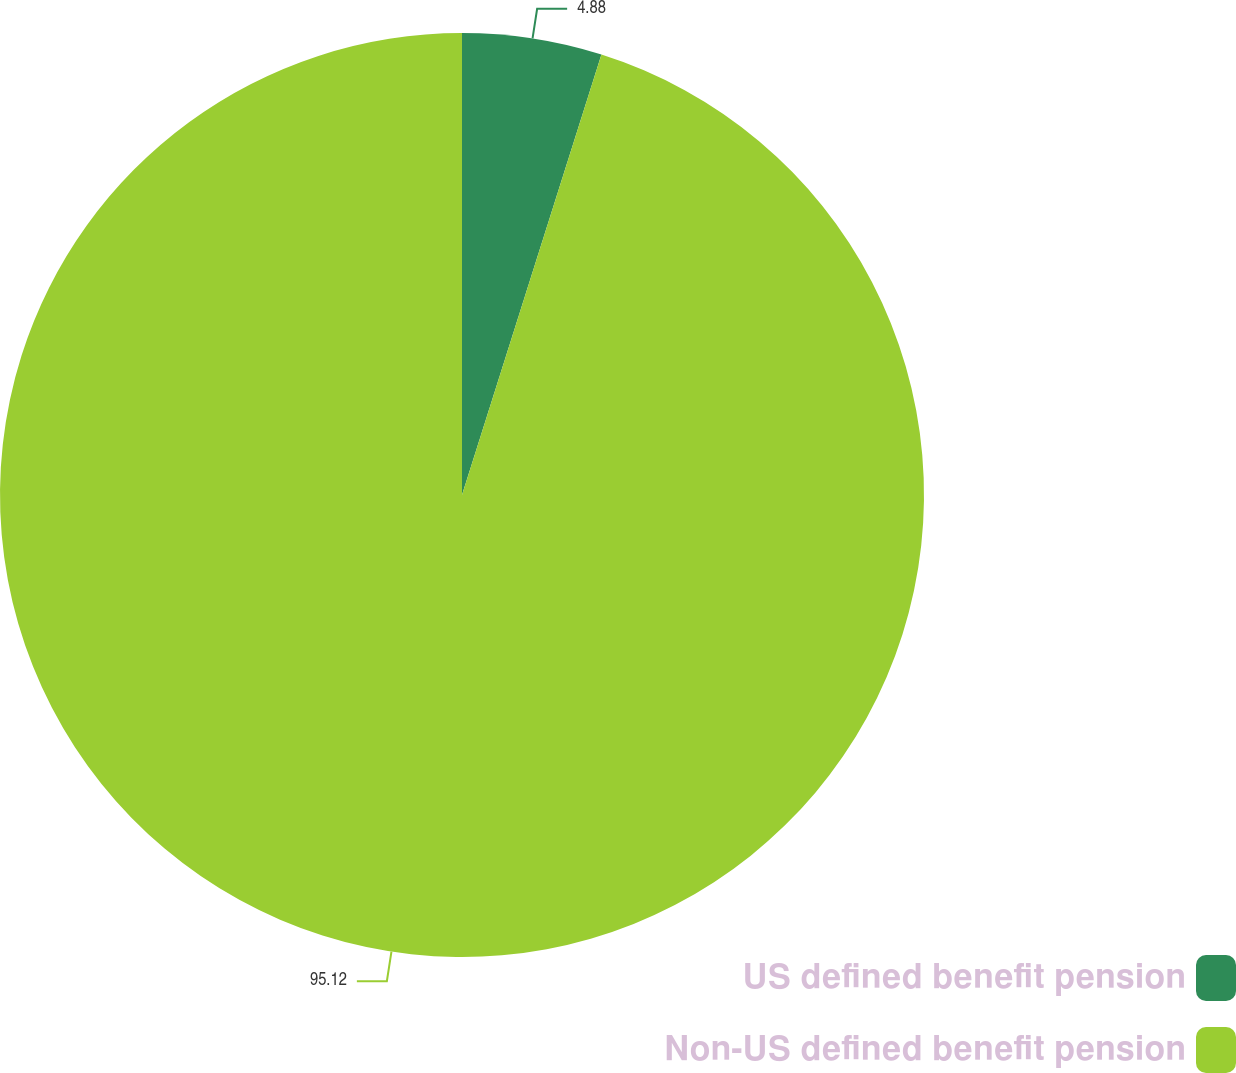Convert chart to OTSL. <chart><loc_0><loc_0><loc_500><loc_500><pie_chart><fcel>US defined benefit pension<fcel>Non-US defined benefit pension<nl><fcel>4.88%<fcel>95.12%<nl></chart> 